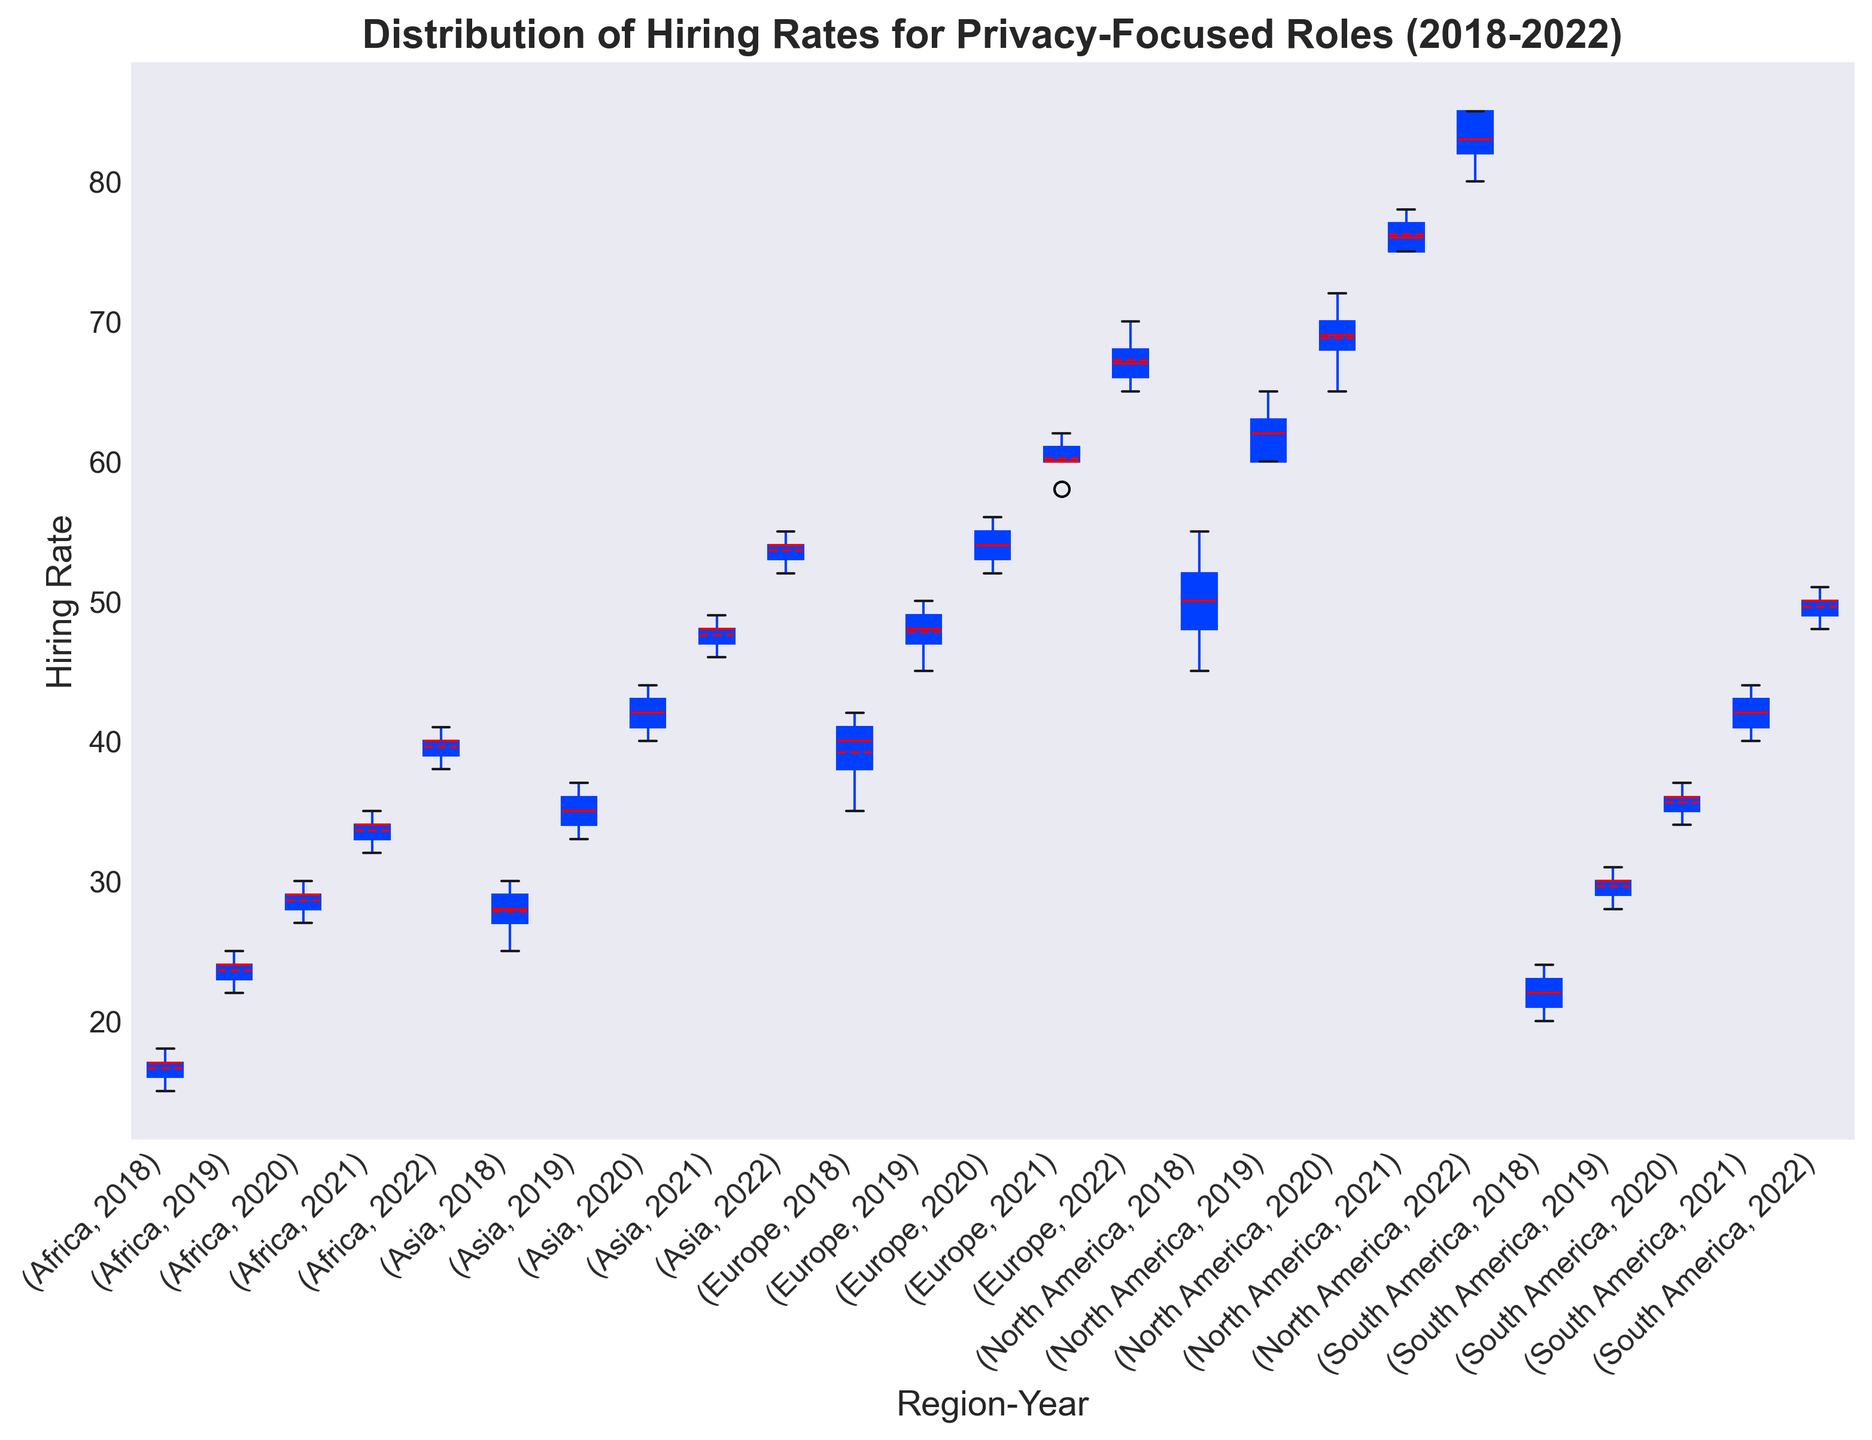Which region had the highest median hiring rate in 2022? To determine the region with the highest median hiring rate in 2022, observe the center line within each box plot labeled for 2022 across different regions. North America has the highest median line compared to other regions.
Answer: North America Which region showed the most significant increase in median hiring rate from 2018 to 2022? To find the region with the most significant increase, compare the median lines (center lines within the boxes) for each region from 2018 to 2022. North America's median hiring rate has the largest difference, indicating the most significant increase.
Answer: North America What was the interquartile range (IQR) for the hiring rates in Europe in 2020? The interquartile range is the difference between the third quartile (top edge of the box) and the first quartile (bottom edge of the box). For Europe in 2020, the IQR spans from approximately 53 to 55, so the IQR is 55 - 53 = 2.
Answer: 2 Which region had the highest variability in hiring rates in 2019? The region with the highest variability will have the largest box height (distance between the first and third quartiles) and potentially longer whiskers. For 2019, North America has the tallest box, reflecting more variability in its hiring rates.
Answer: North America Compare the mean hiring rates of Asia and South America in 2022. Which one is higher? The mean hiring rate is depicted by the dashed line within each box. In 2022, observing the mean lines, Asia's mean hiring rate is slightly higher than South America's.
Answer: Asia Did any regions show any outliers in hiring rates between 2018 and 2022? If so, which ones? Outliers are typically displayed as individual points outside the whiskers of the box plot. Observing the plots, none of the regions show distinct outliers for the hiring rates between 2018 and 2022.
Answer: None Which region had the most consistent (least variable) hiring rates in 2021? The region with the least variability will have the smallest box height and shorter whiskers. For 2021, Asia has the smallest box, indicating the most consistent hiring rates.
Answer: Asia Was the median hiring rate for South America higher in 2019 or 2020? To compare, look at the center lines within the boxes for South America in 2019 and 2020. The median in 2020 (approximately at 36) is higher than the median in 2019 (approximately at 30).
Answer: 2020 How did the hiring rates in Africa change from 2020 to 2021? To observe the change, compare the heights and positions of the boxes from 2020 to 2021. Africa's median hiring rate increased as the median line in 2021 is higher than in 2020. The overall distribution also shifted upwards.
Answer: Increased Which region had the lowest median hiring rate in 2018? Compare the center lines within the boxes for each region in 2018. Africa's median line is the lowest among all regions.
Answer: Africa 